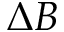<formula> <loc_0><loc_0><loc_500><loc_500>\Delta B</formula> 